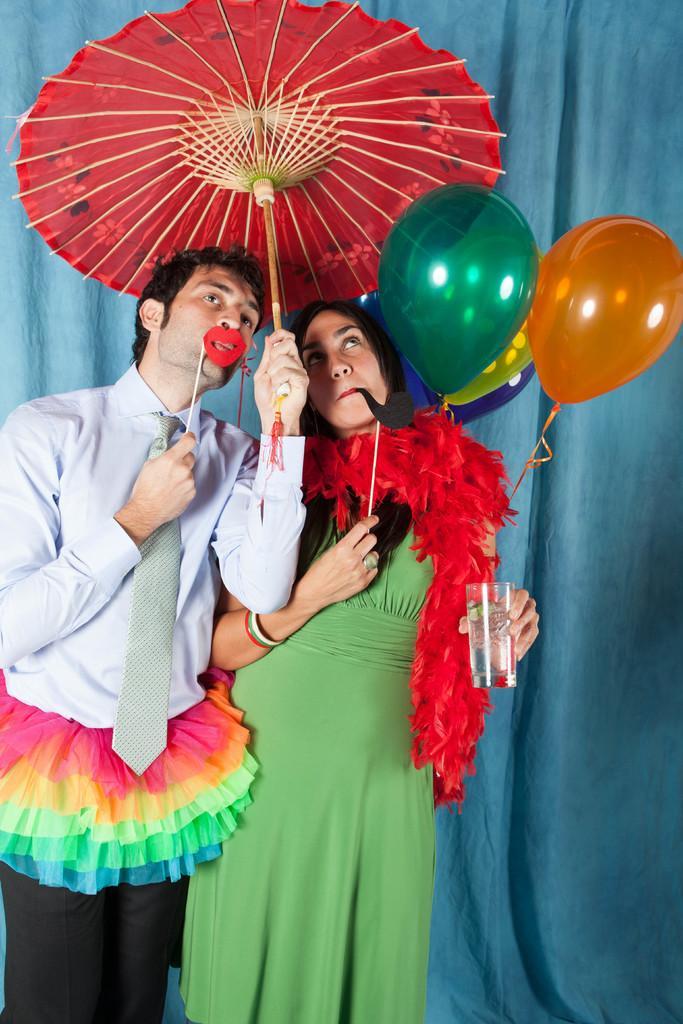Please provide a concise description of this image. In this image in the front there are persons standing and the woman standing on the right side is holding balloons and a glass in her hand and the man standing on the left side is holding an umbrella which is red in colour. In the background there is a curtain which is blue in colour. 